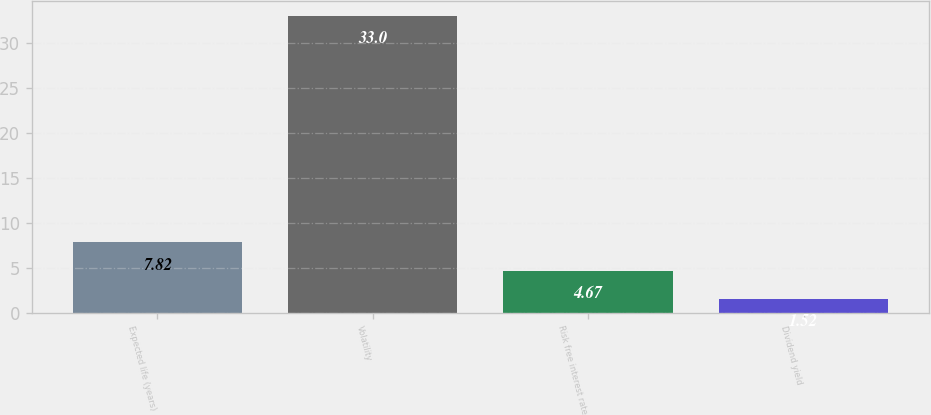<chart> <loc_0><loc_0><loc_500><loc_500><bar_chart><fcel>Expected life (years)<fcel>Volatility<fcel>Risk free interest rate<fcel>Dividend yield<nl><fcel>7.82<fcel>33<fcel>4.67<fcel>1.52<nl></chart> 